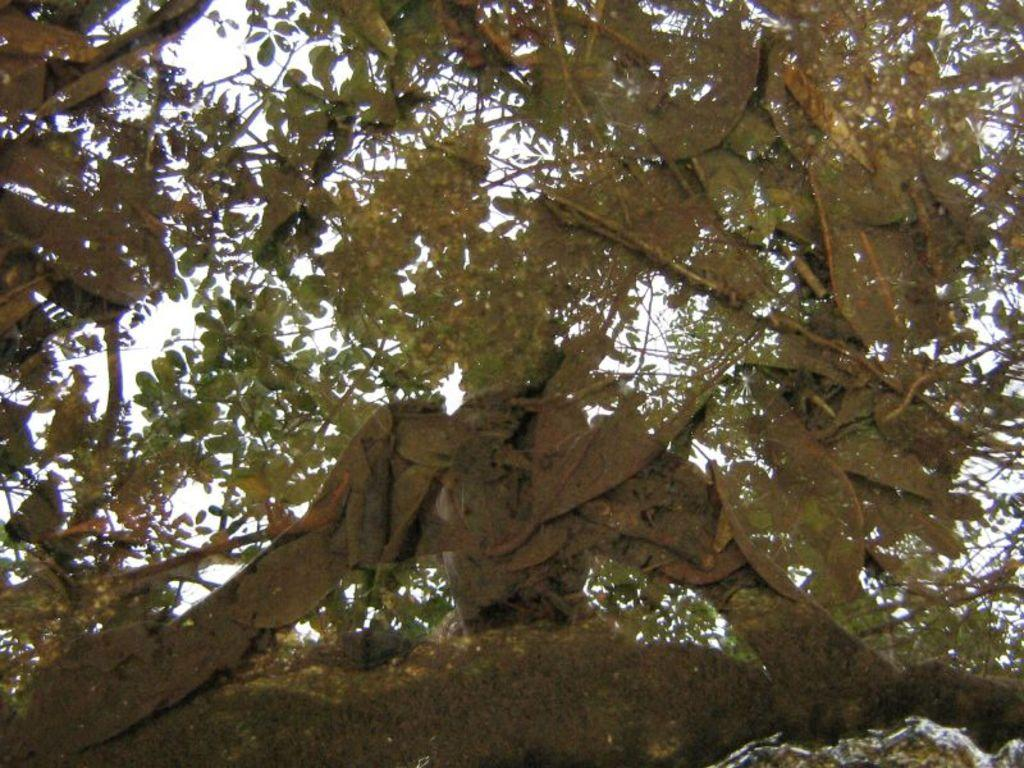What is the main subject in the image? There is a tree in the image. Can you describe the tree in more detail? The tree has multiple branches. What can be seen in the background of the image? There is a sky visible in the background of the image. What is the limit of the clouds in the image? There are no clouds present in the image, so there is no limit to discuss. 